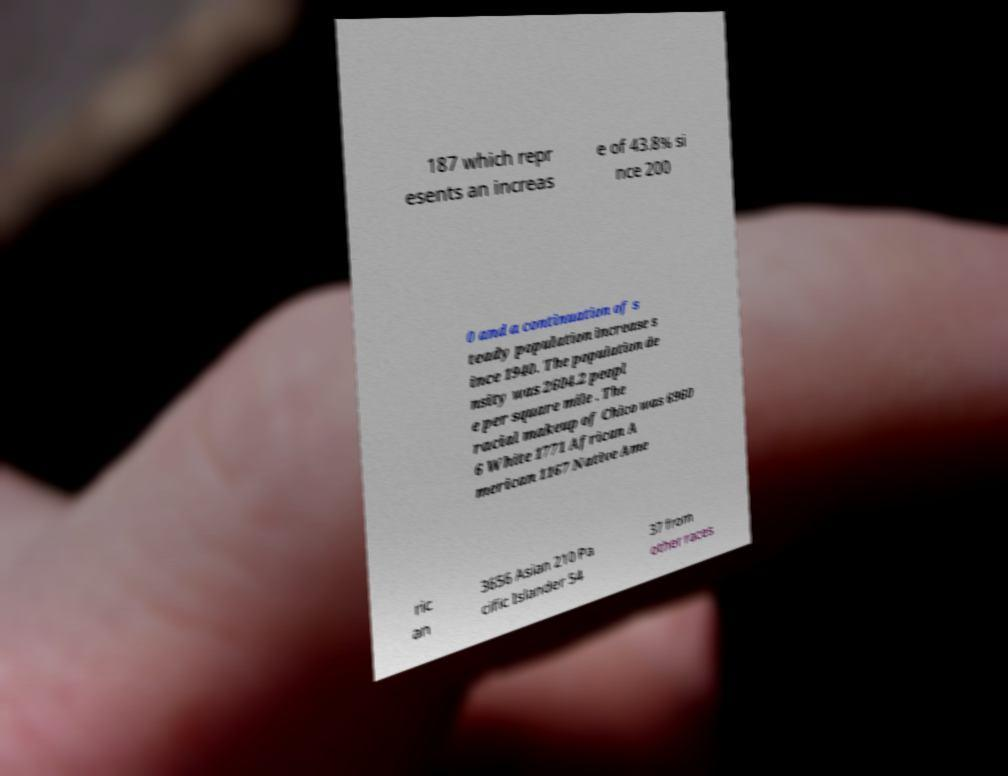Can you read and provide the text displayed in the image?This photo seems to have some interesting text. Can you extract and type it out for me? 187 which repr esents an increas e of 43.8% si nce 200 0 and a continuation of s teady population increase s ince 1940. The population de nsity was 2604.2 peopl e per square mile . The racial makeup of Chico was 6960 6 White 1771 African A merican 1167 Native Ame ric an 3656 Asian 210 Pa cific Islander 54 37 from other races 